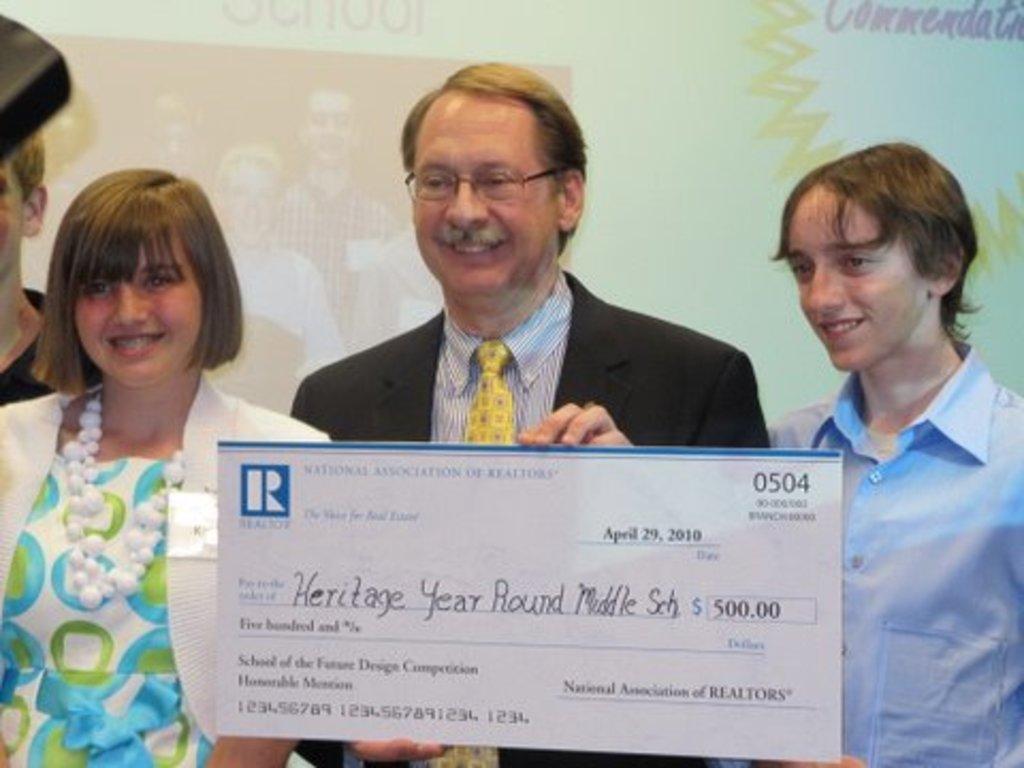Could you give a brief overview of what you see in this image? In this picture we can see a person wearing a spectacle and smiling. He is holding a cheque. We can see some text and numbers on this cheque. There are a few people visible from left to right. We can see some text and the reflections of a few people on a white background. 